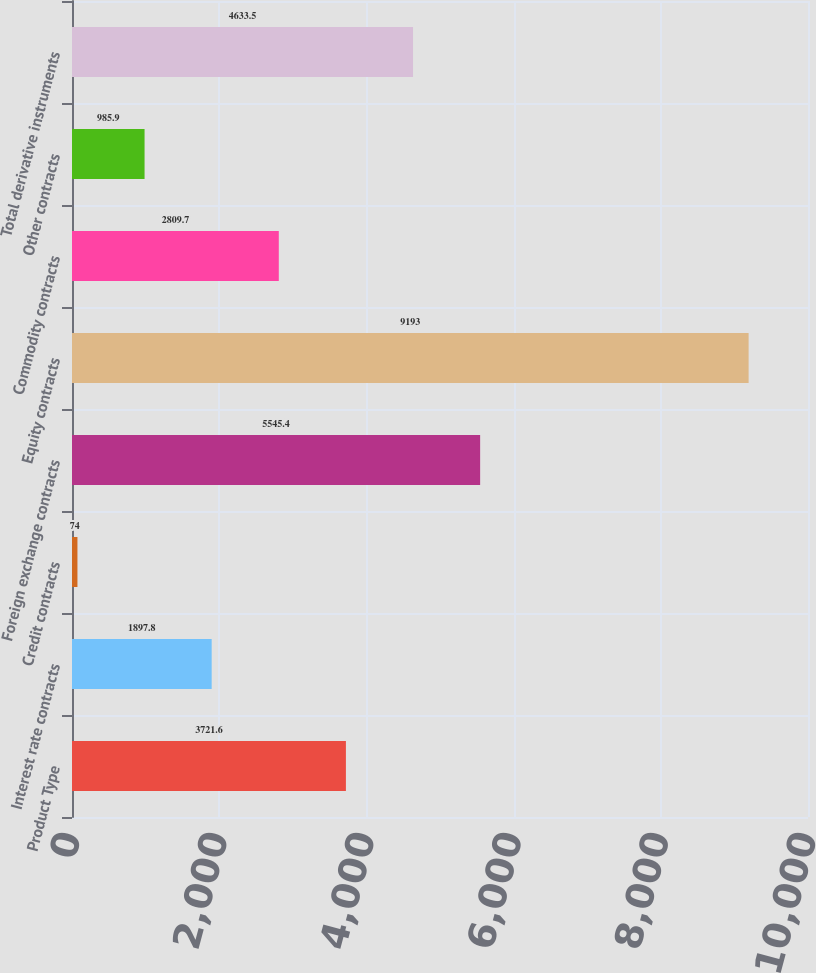Convert chart. <chart><loc_0><loc_0><loc_500><loc_500><bar_chart><fcel>Product Type<fcel>Interest rate contracts<fcel>Credit contracts<fcel>Foreign exchange contracts<fcel>Equity contracts<fcel>Commodity contracts<fcel>Other contracts<fcel>Total derivative instruments<nl><fcel>3721.6<fcel>1897.8<fcel>74<fcel>5545.4<fcel>9193<fcel>2809.7<fcel>985.9<fcel>4633.5<nl></chart> 